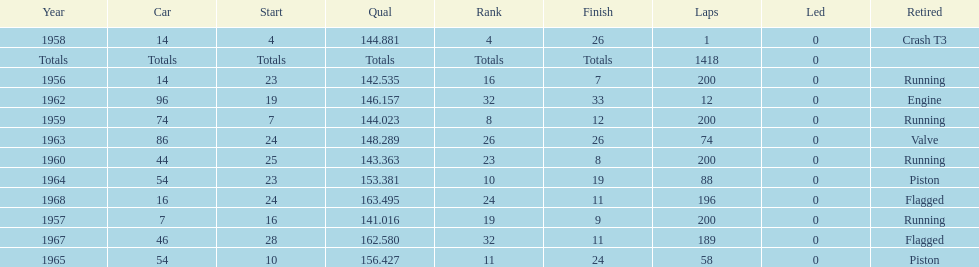What was the last year that it finished the race? 1968. 